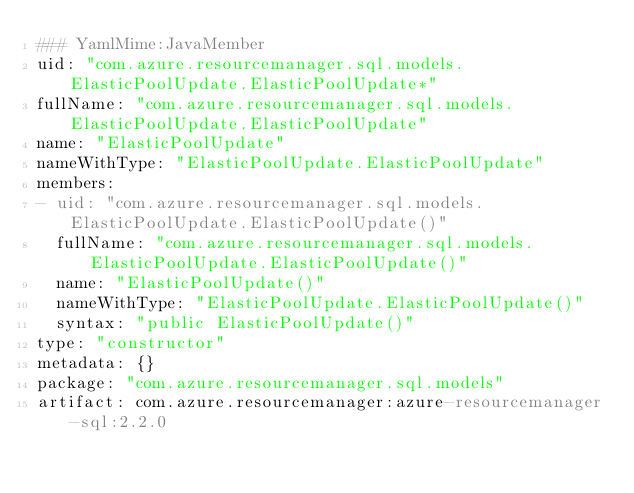Convert code to text. <code><loc_0><loc_0><loc_500><loc_500><_YAML_>### YamlMime:JavaMember
uid: "com.azure.resourcemanager.sql.models.ElasticPoolUpdate.ElasticPoolUpdate*"
fullName: "com.azure.resourcemanager.sql.models.ElasticPoolUpdate.ElasticPoolUpdate"
name: "ElasticPoolUpdate"
nameWithType: "ElasticPoolUpdate.ElasticPoolUpdate"
members:
- uid: "com.azure.resourcemanager.sql.models.ElasticPoolUpdate.ElasticPoolUpdate()"
  fullName: "com.azure.resourcemanager.sql.models.ElasticPoolUpdate.ElasticPoolUpdate()"
  name: "ElasticPoolUpdate()"
  nameWithType: "ElasticPoolUpdate.ElasticPoolUpdate()"
  syntax: "public ElasticPoolUpdate()"
type: "constructor"
metadata: {}
package: "com.azure.resourcemanager.sql.models"
artifact: com.azure.resourcemanager:azure-resourcemanager-sql:2.2.0
</code> 